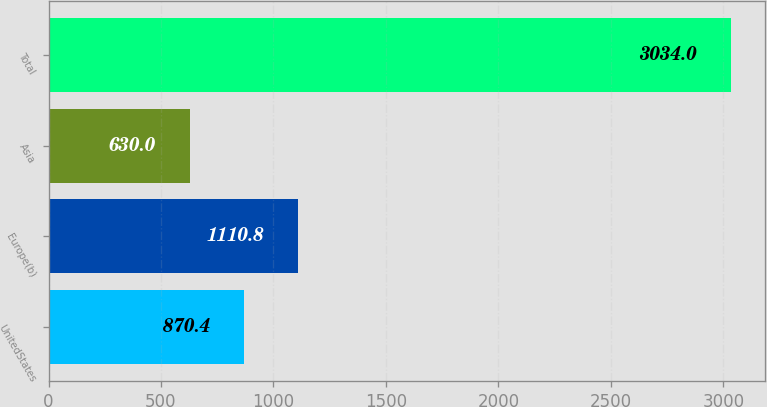<chart> <loc_0><loc_0><loc_500><loc_500><bar_chart><fcel>UnitedStates<fcel>Europe(b)<fcel>Asia<fcel>Total<nl><fcel>870.4<fcel>1110.8<fcel>630<fcel>3034<nl></chart> 